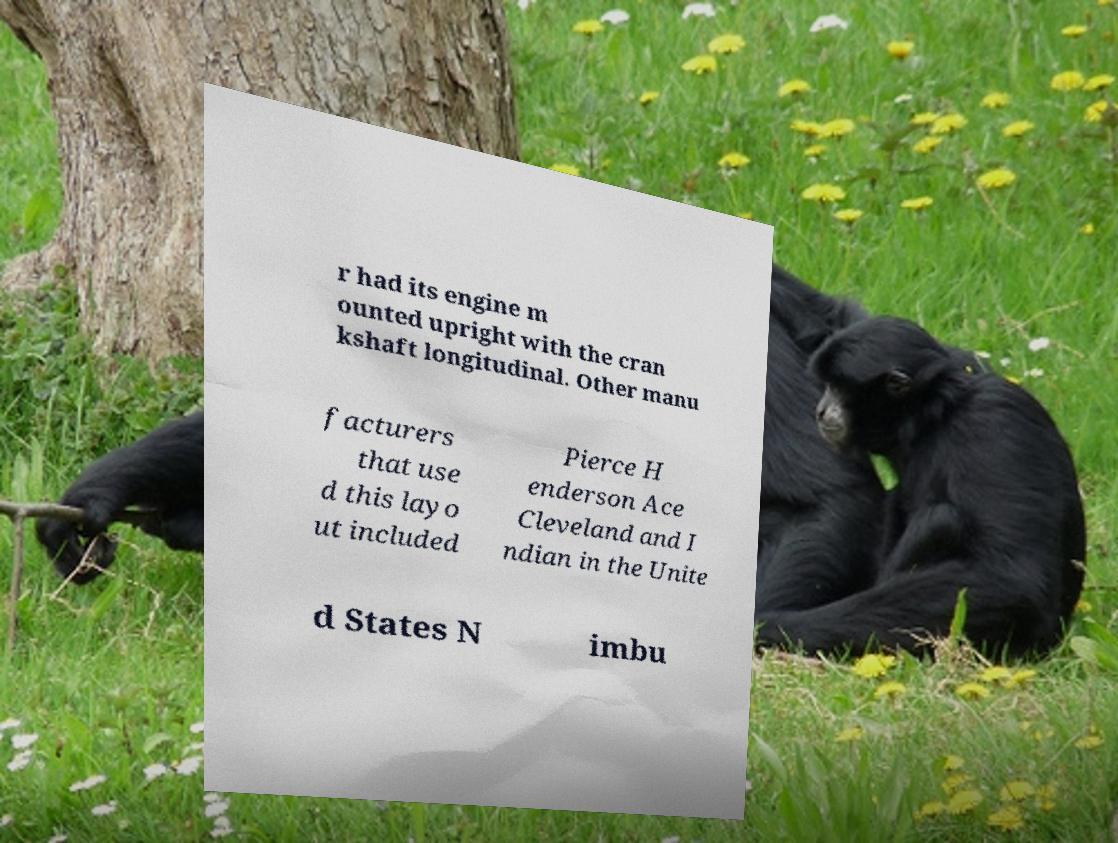Please read and relay the text visible in this image. What does it say? r had its engine m ounted upright with the cran kshaft longitudinal. Other manu facturers that use d this layo ut included Pierce H enderson Ace Cleveland and I ndian in the Unite d States N imbu 